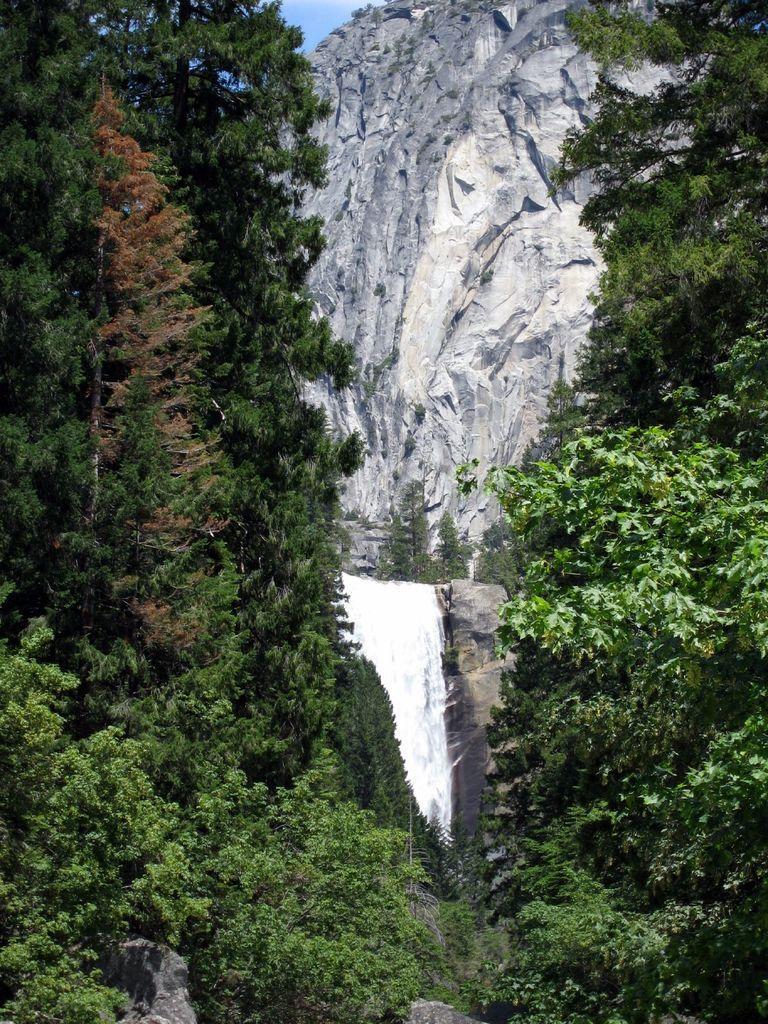How would you summarize this image in a sentence or two? In the image we can see some trees and hills. Behind the hill there is sky. 